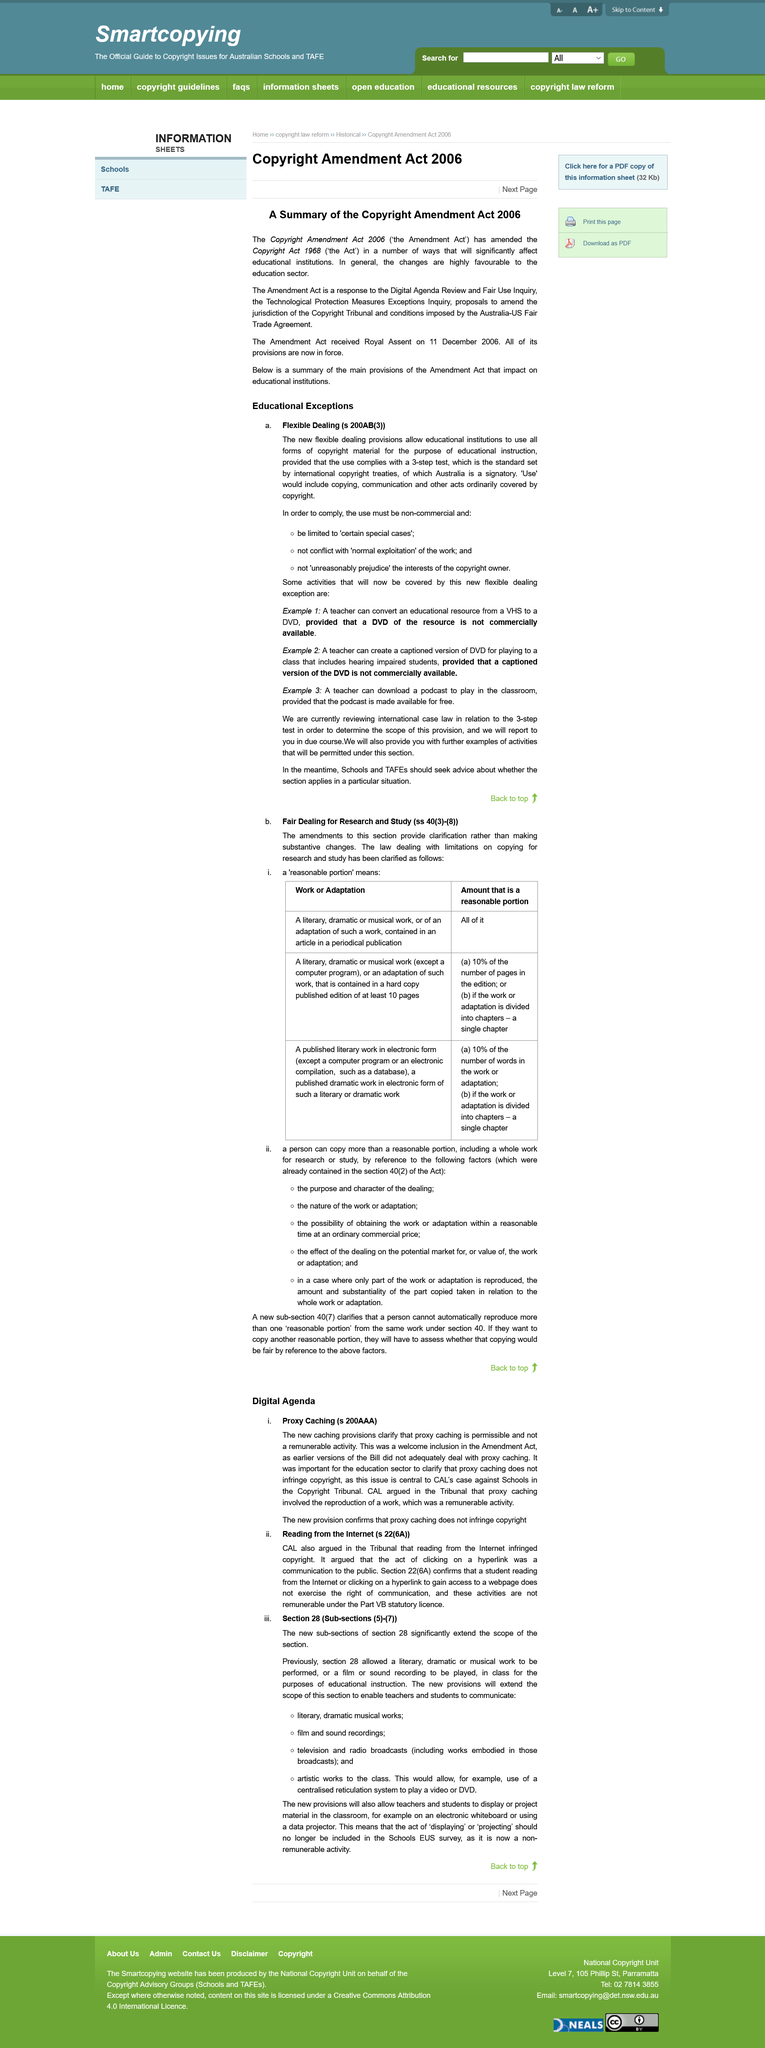Indicate a few pertinent items in this graphic. The "Use" of the copyrighted work includes, but is not limited to, the act of copying and communication, as well as any other acts that are ordinarily protected under copyright law. The new caching provisions clarify that proxy caching is permissible and not a remunerable activity. The Copyright Amendment Act is a response to the Digital Agenda Review and Fair Use Inquiry, the Technological Protection Measures Exceptions Inquiry, proposals to amend the jurisdiction of the Copyright Tribunal, and conditions imposed by the Australia-US Fair Trade Agreement. It is reasonable to use a portion of a published literary work from an article in a periodical publication for research purposes, provided that it is not an excessive or unreasonable amount. The amendments in the second provide clarification rather than substantive changes. 